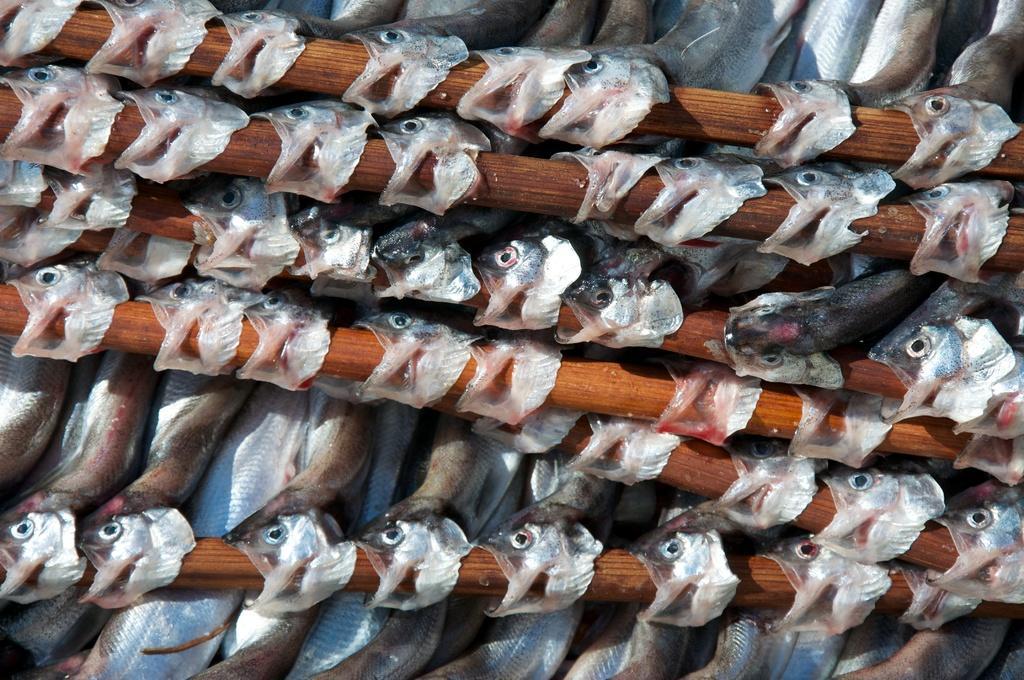Describe this image in one or two sentences. In this image we can see wooden sticks. And also there are many fish. 